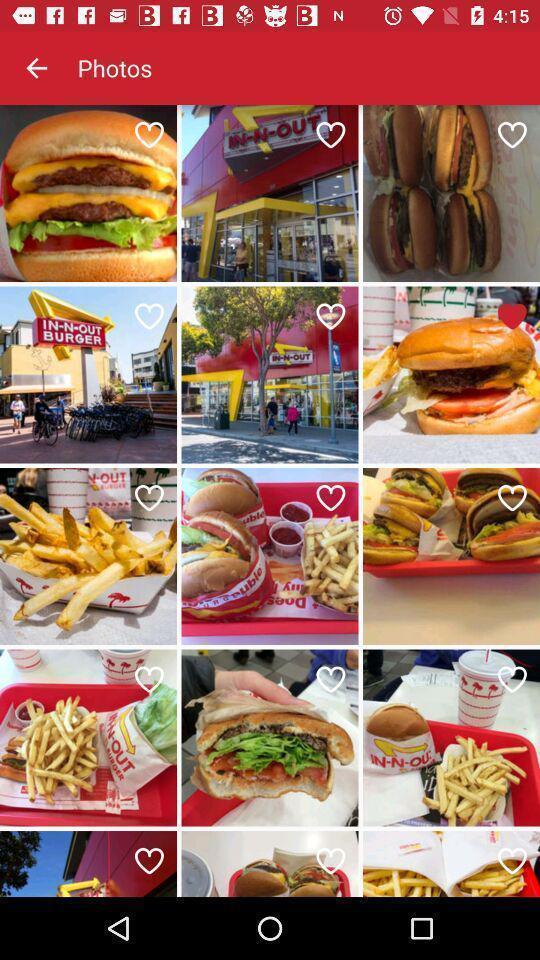What is the overall content of this screenshot? Screen shows multiple food images. 